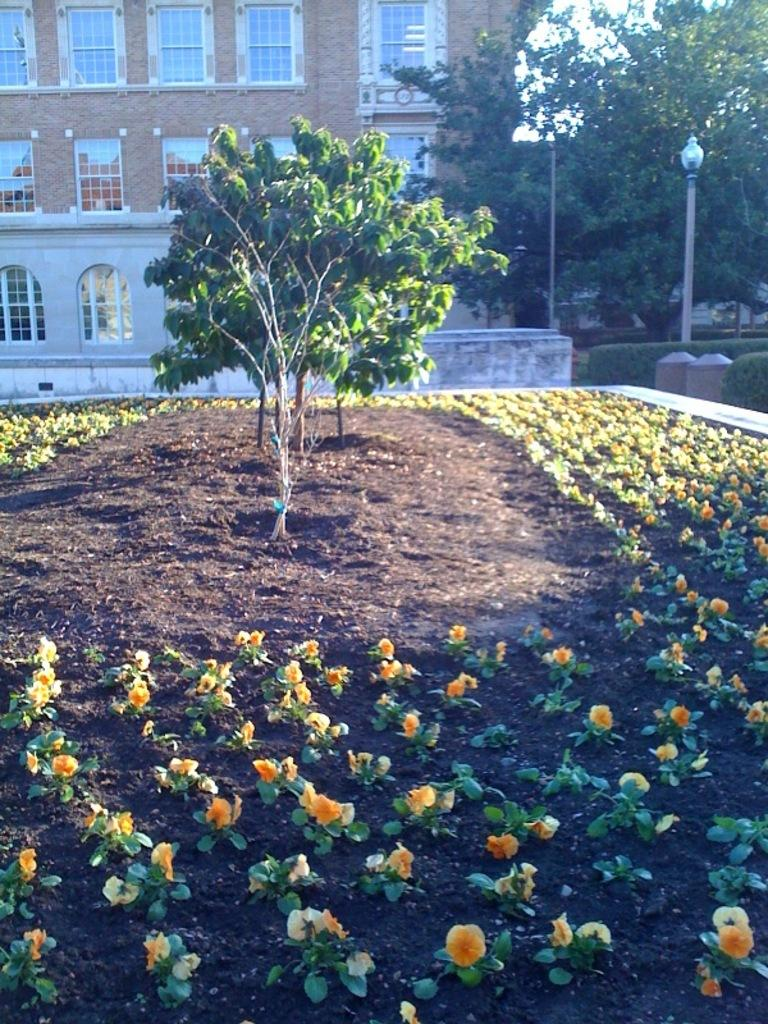What structure is visible in the image? There is a building in the image. What type of vegetation is in front of the building? There are trees in front of the building. What type of flora is also present in front of the building? There are flowers in front of the building. What type of shirt is the building wearing in the image? The building is not wearing a shirt, as it is a structure and not a living being. Is there any indication of pain or discomfort experienced by the building in the image? The building is an inanimate object and therefore cannot experience pain or discomfort. 